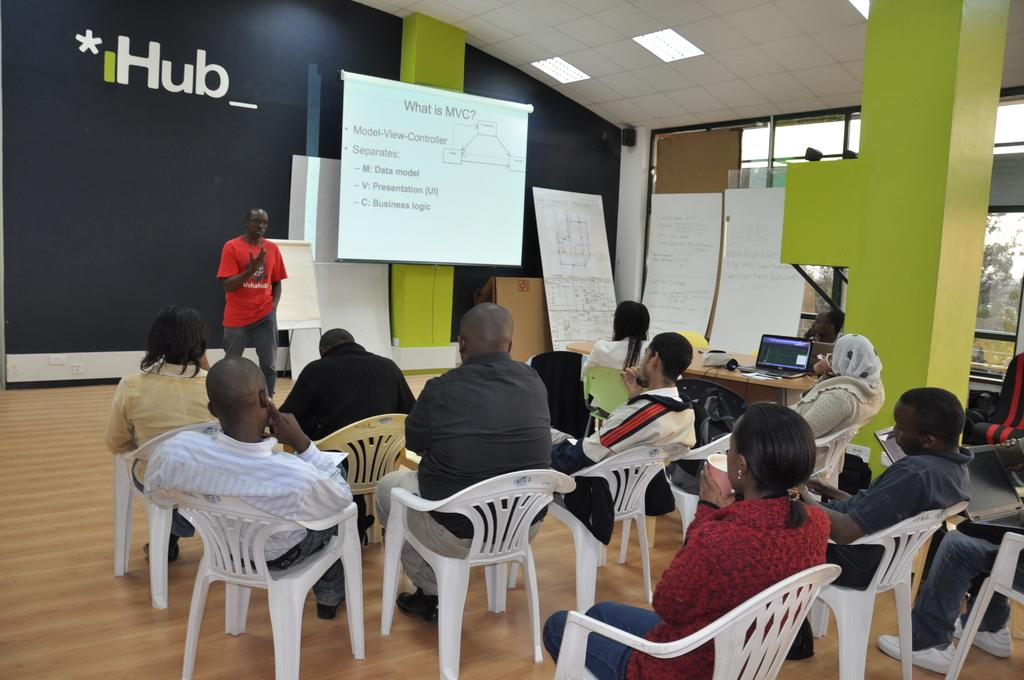How many people are in the image? There is a group of people in the image. What are the people in the image doing? The people are sitting. Is there anyone standing in the image? Yes, there is a man standing in the image. What can be seen on the presentation screen in the image? The facts provided do not specify what is on the presentation screen. What color are the cherries on the chalkboard in the image? There is no chalkboard or cherries present in the image. 